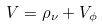Convert formula to latex. <formula><loc_0><loc_0><loc_500><loc_500>V = \rho _ { \nu } + V _ { \phi }</formula> 